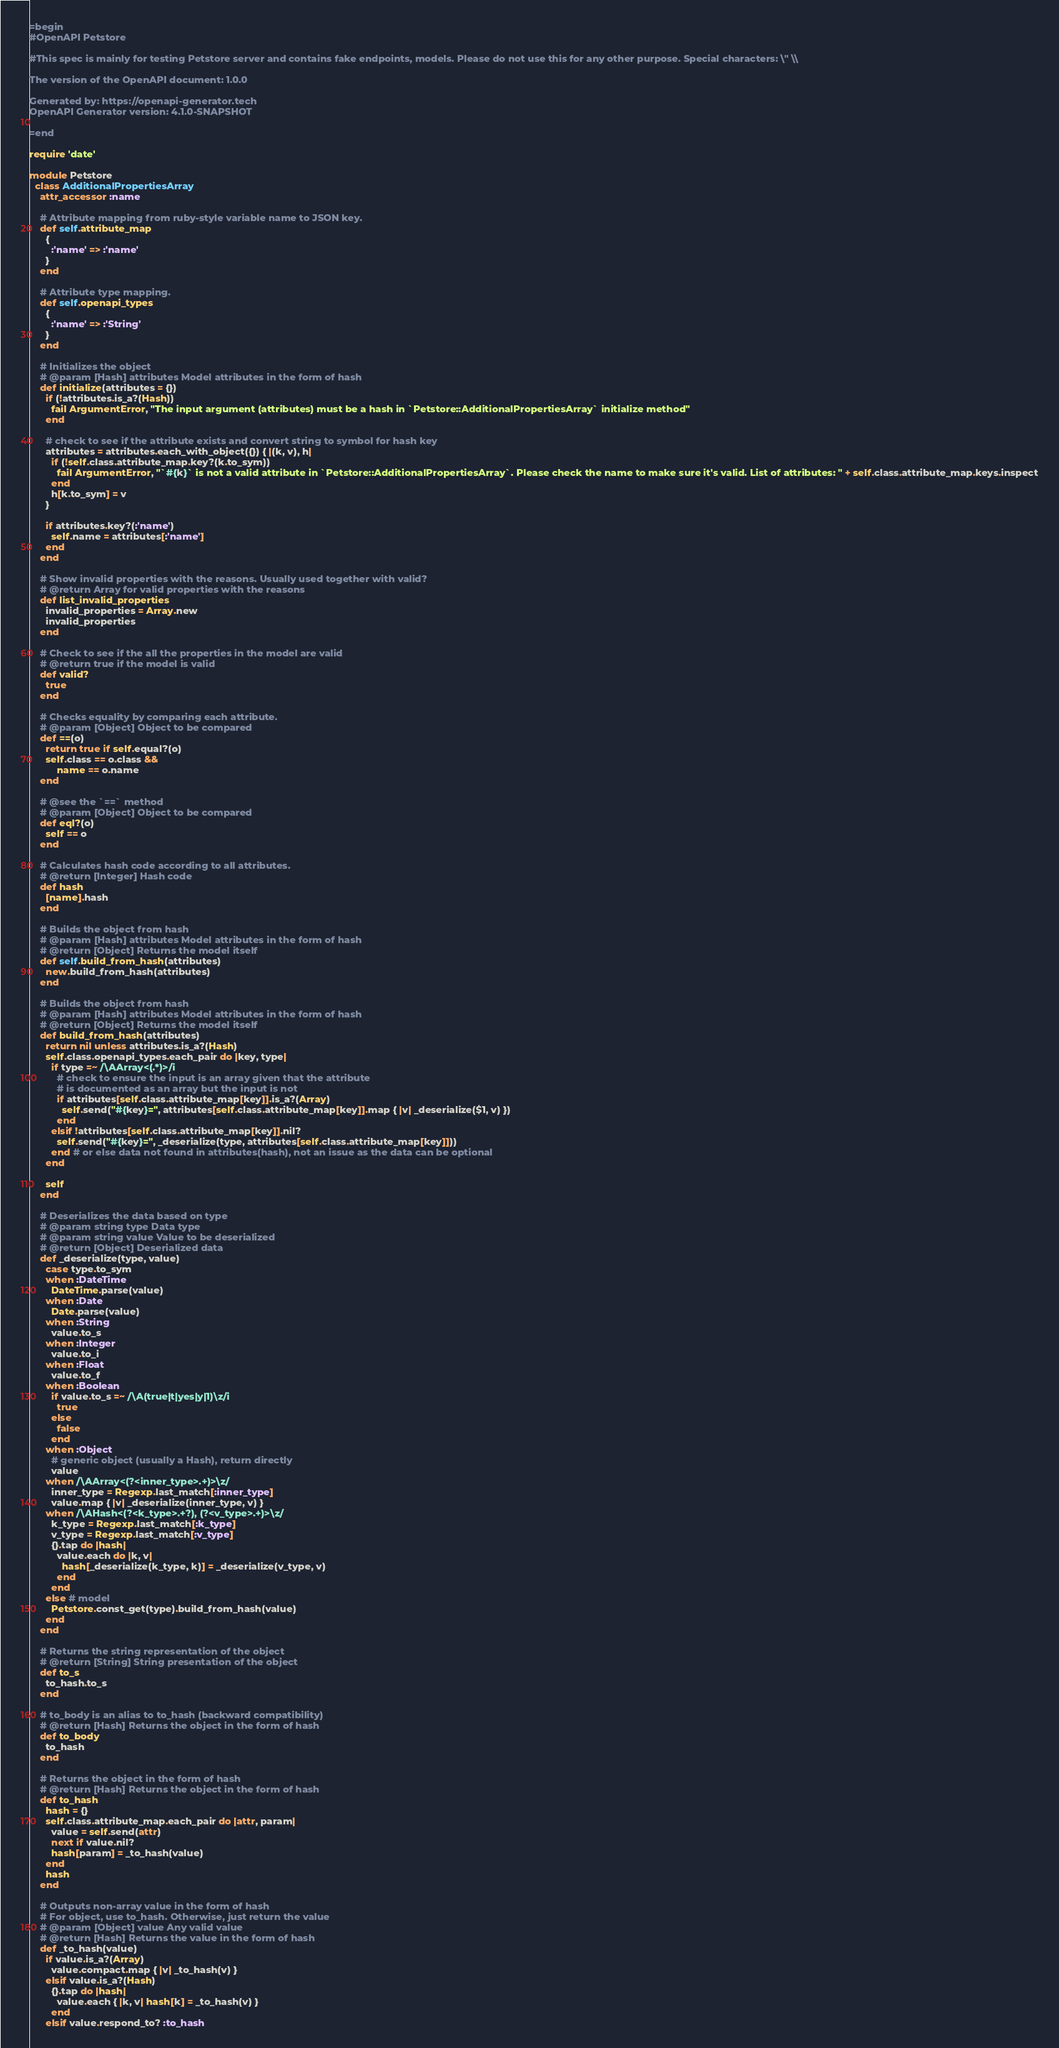Convert code to text. <code><loc_0><loc_0><loc_500><loc_500><_Ruby_>=begin
#OpenAPI Petstore

#This spec is mainly for testing Petstore server and contains fake endpoints, models. Please do not use this for any other purpose. Special characters: \" \\

The version of the OpenAPI document: 1.0.0

Generated by: https://openapi-generator.tech
OpenAPI Generator version: 4.1.0-SNAPSHOT

=end

require 'date'

module Petstore
  class AdditionalPropertiesArray
    attr_accessor :name

    # Attribute mapping from ruby-style variable name to JSON key.
    def self.attribute_map
      {
        :'name' => :'name'
      }
    end

    # Attribute type mapping.
    def self.openapi_types
      {
        :'name' => :'String'
      }
    end

    # Initializes the object
    # @param [Hash] attributes Model attributes in the form of hash
    def initialize(attributes = {})
      if (!attributes.is_a?(Hash))
        fail ArgumentError, "The input argument (attributes) must be a hash in `Petstore::AdditionalPropertiesArray` initialize method"
      end

      # check to see if the attribute exists and convert string to symbol for hash key
      attributes = attributes.each_with_object({}) { |(k, v), h|
        if (!self.class.attribute_map.key?(k.to_sym))
          fail ArgumentError, "`#{k}` is not a valid attribute in `Petstore::AdditionalPropertiesArray`. Please check the name to make sure it's valid. List of attributes: " + self.class.attribute_map.keys.inspect
        end
        h[k.to_sym] = v
      }

      if attributes.key?(:'name')
        self.name = attributes[:'name']
      end
    end

    # Show invalid properties with the reasons. Usually used together with valid?
    # @return Array for valid properties with the reasons
    def list_invalid_properties
      invalid_properties = Array.new
      invalid_properties
    end

    # Check to see if the all the properties in the model are valid
    # @return true if the model is valid
    def valid?
      true
    end

    # Checks equality by comparing each attribute.
    # @param [Object] Object to be compared
    def ==(o)
      return true if self.equal?(o)
      self.class == o.class &&
          name == o.name
    end

    # @see the `==` method
    # @param [Object] Object to be compared
    def eql?(o)
      self == o
    end

    # Calculates hash code according to all attributes.
    # @return [Integer] Hash code
    def hash
      [name].hash
    end

    # Builds the object from hash
    # @param [Hash] attributes Model attributes in the form of hash
    # @return [Object] Returns the model itself
    def self.build_from_hash(attributes)
      new.build_from_hash(attributes)
    end

    # Builds the object from hash
    # @param [Hash] attributes Model attributes in the form of hash
    # @return [Object] Returns the model itself
    def build_from_hash(attributes)
      return nil unless attributes.is_a?(Hash)
      self.class.openapi_types.each_pair do |key, type|
        if type =~ /\AArray<(.*)>/i
          # check to ensure the input is an array given that the attribute
          # is documented as an array but the input is not
          if attributes[self.class.attribute_map[key]].is_a?(Array)
            self.send("#{key}=", attributes[self.class.attribute_map[key]].map { |v| _deserialize($1, v) })
          end
        elsif !attributes[self.class.attribute_map[key]].nil?
          self.send("#{key}=", _deserialize(type, attributes[self.class.attribute_map[key]]))
        end # or else data not found in attributes(hash), not an issue as the data can be optional
      end

      self
    end

    # Deserializes the data based on type
    # @param string type Data type
    # @param string value Value to be deserialized
    # @return [Object] Deserialized data
    def _deserialize(type, value)
      case type.to_sym
      when :DateTime
        DateTime.parse(value)
      when :Date
        Date.parse(value)
      when :String
        value.to_s
      when :Integer
        value.to_i
      when :Float
        value.to_f
      when :Boolean
        if value.to_s =~ /\A(true|t|yes|y|1)\z/i
          true
        else
          false
        end
      when :Object
        # generic object (usually a Hash), return directly
        value
      when /\AArray<(?<inner_type>.+)>\z/
        inner_type = Regexp.last_match[:inner_type]
        value.map { |v| _deserialize(inner_type, v) }
      when /\AHash<(?<k_type>.+?), (?<v_type>.+)>\z/
        k_type = Regexp.last_match[:k_type]
        v_type = Regexp.last_match[:v_type]
        {}.tap do |hash|
          value.each do |k, v|
            hash[_deserialize(k_type, k)] = _deserialize(v_type, v)
          end
        end
      else # model
        Petstore.const_get(type).build_from_hash(value)
      end
    end

    # Returns the string representation of the object
    # @return [String] String presentation of the object
    def to_s
      to_hash.to_s
    end

    # to_body is an alias to to_hash (backward compatibility)
    # @return [Hash] Returns the object in the form of hash
    def to_body
      to_hash
    end

    # Returns the object in the form of hash
    # @return [Hash] Returns the object in the form of hash
    def to_hash
      hash = {}
      self.class.attribute_map.each_pair do |attr, param|
        value = self.send(attr)
        next if value.nil?
        hash[param] = _to_hash(value)
      end
      hash
    end

    # Outputs non-array value in the form of hash
    # For object, use to_hash. Otherwise, just return the value
    # @param [Object] value Any valid value
    # @return [Hash] Returns the value in the form of hash
    def _to_hash(value)
      if value.is_a?(Array)
        value.compact.map { |v| _to_hash(v) }
      elsif value.is_a?(Hash)
        {}.tap do |hash|
          value.each { |k, v| hash[k] = _to_hash(v) }
        end
      elsif value.respond_to? :to_hash</code> 